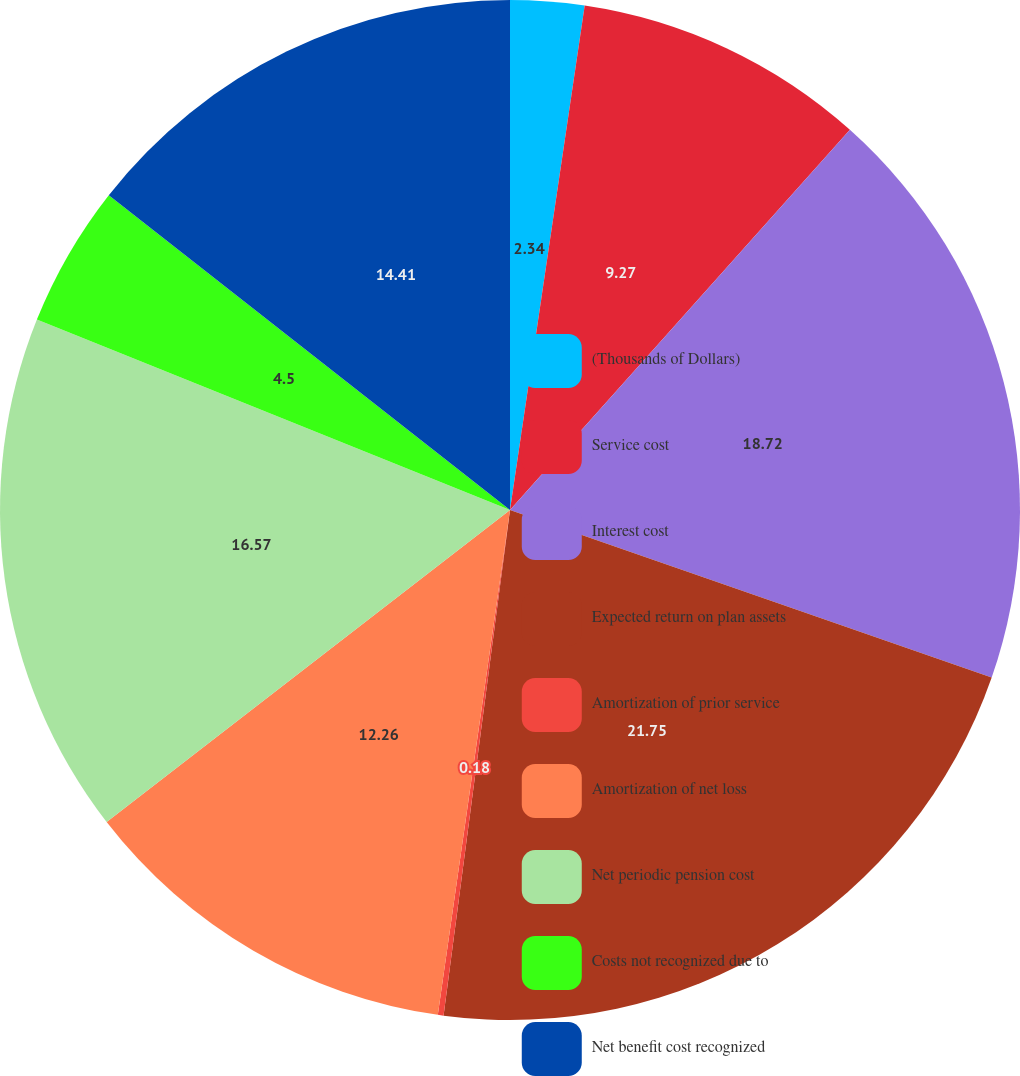Convert chart. <chart><loc_0><loc_0><loc_500><loc_500><pie_chart><fcel>(Thousands of Dollars)<fcel>Service cost<fcel>Interest cost<fcel>Expected return on plan assets<fcel>Amortization of prior service<fcel>Amortization of net loss<fcel>Net periodic pension cost<fcel>Costs not recognized due to<fcel>Net benefit cost recognized<nl><fcel>2.34%<fcel>9.27%<fcel>18.72%<fcel>21.75%<fcel>0.18%<fcel>12.26%<fcel>16.57%<fcel>4.5%<fcel>14.41%<nl></chart> 